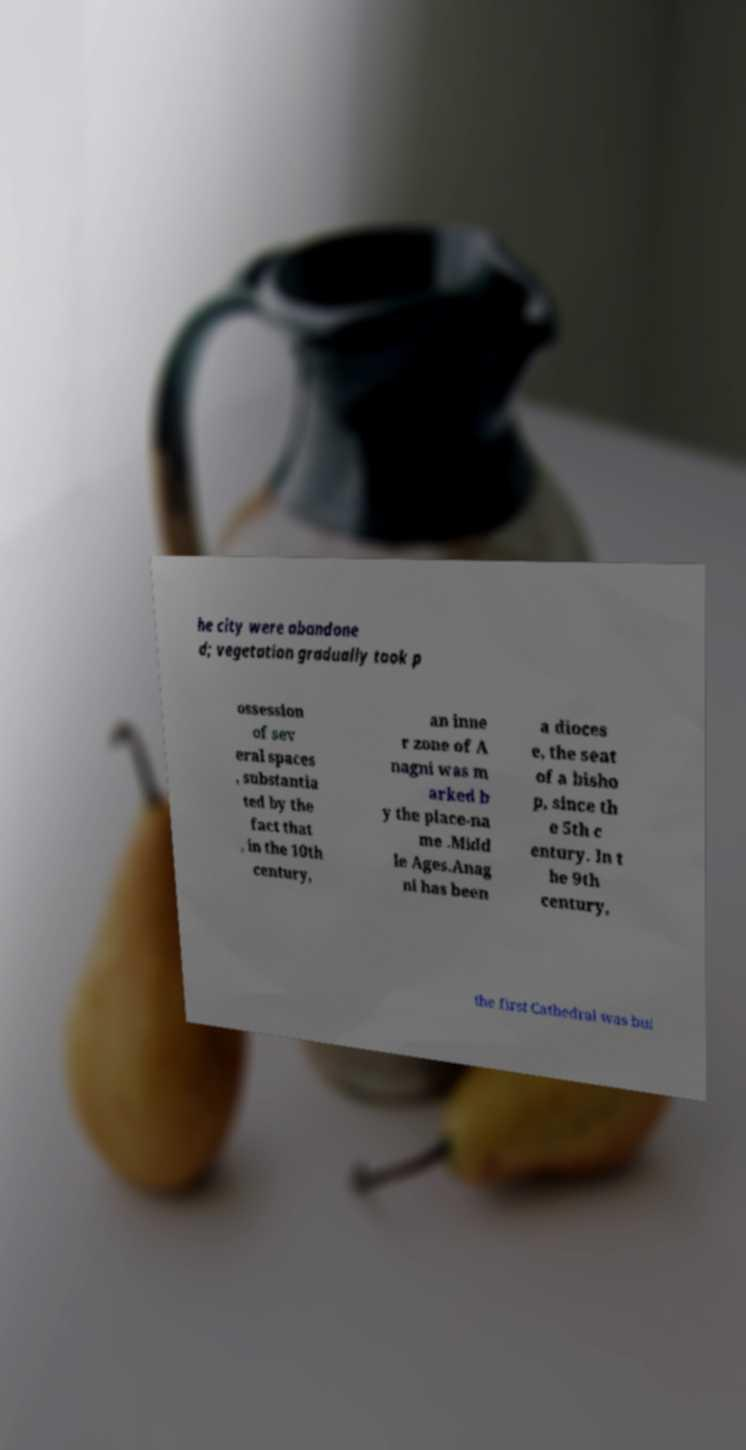There's text embedded in this image that I need extracted. Can you transcribe it verbatim? he city were abandone d; vegetation gradually took p ossession of sev eral spaces , substantia ted by the fact that , in the 10th century, an inne r zone of A nagni was m arked b y the place-na me .Midd le Ages.Anag ni has been a dioces e, the seat of a bisho p, since th e 5th c entury. In t he 9th century, the first Cathedral was bui 